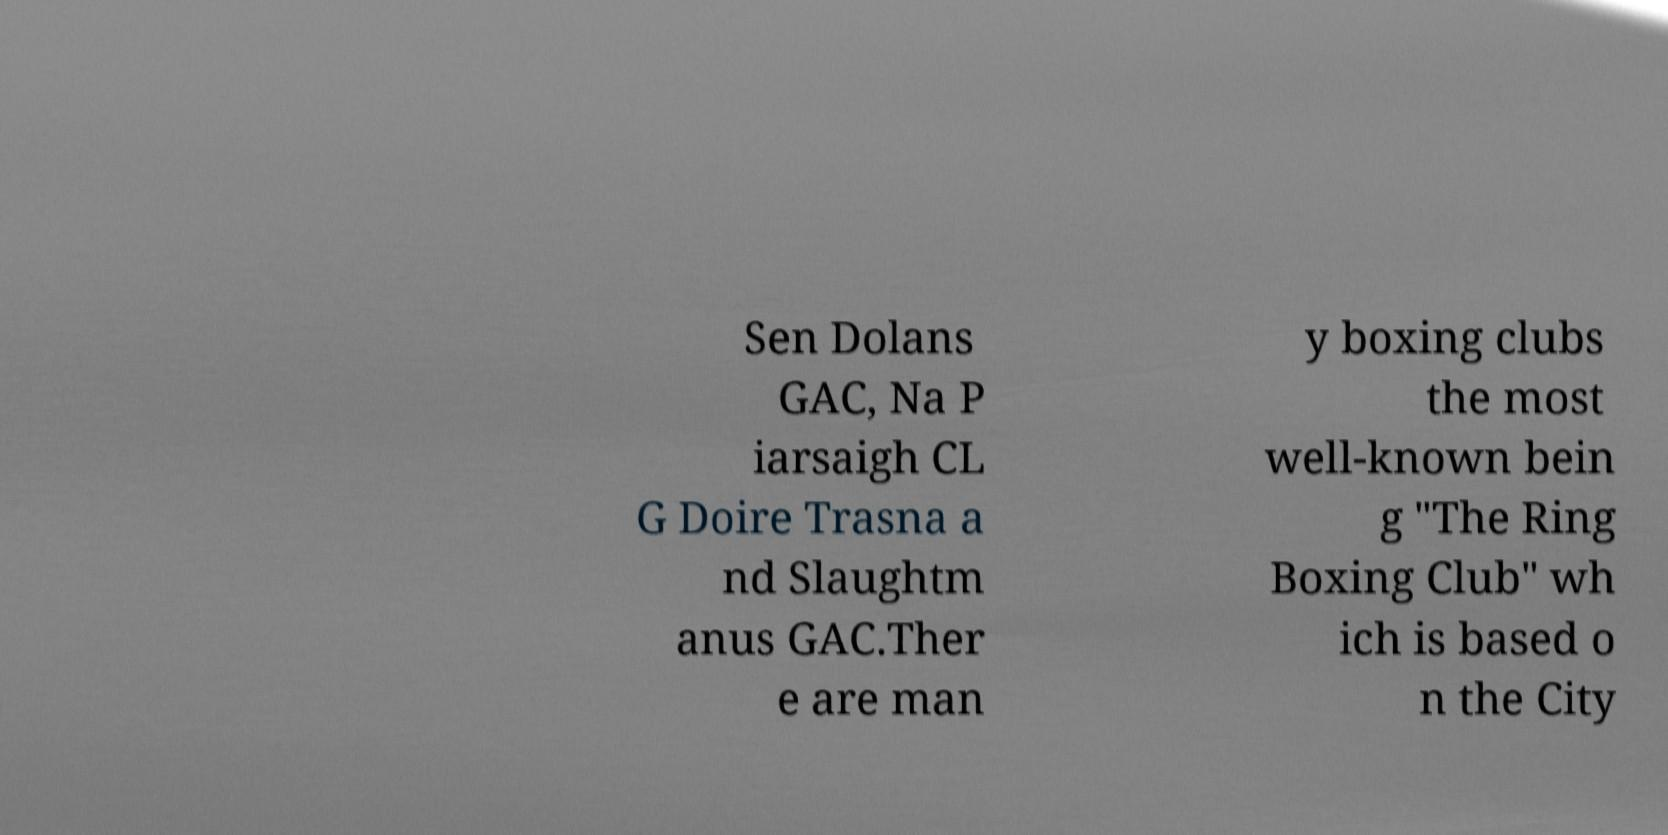Could you assist in decoding the text presented in this image and type it out clearly? Sen Dolans GAC, Na P iarsaigh CL G Doire Trasna a nd Slaughtm anus GAC.Ther e are man y boxing clubs the most well-known bein g "The Ring Boxing Club" wh ich is based o n the City 